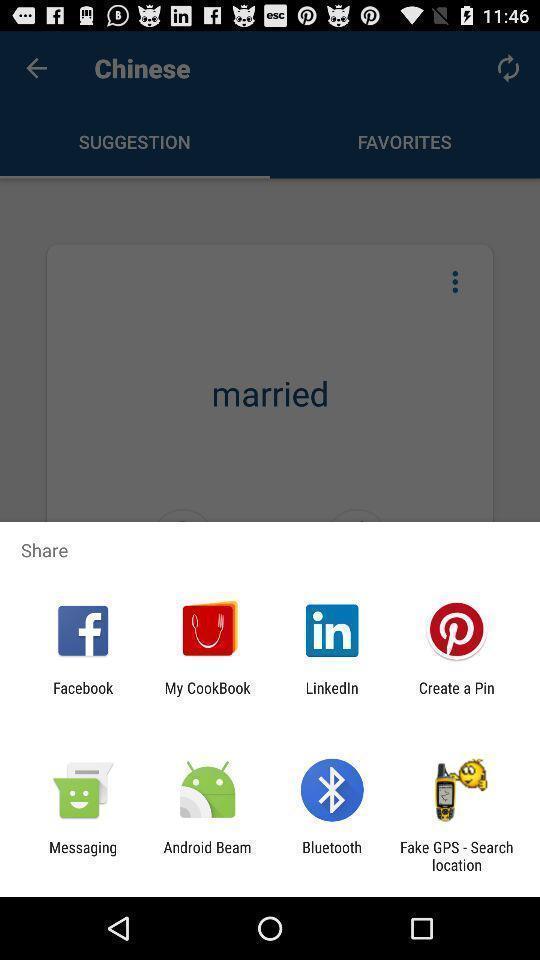Provide a detailed account of this screenshot. Pop-up displaying different applications to share. 